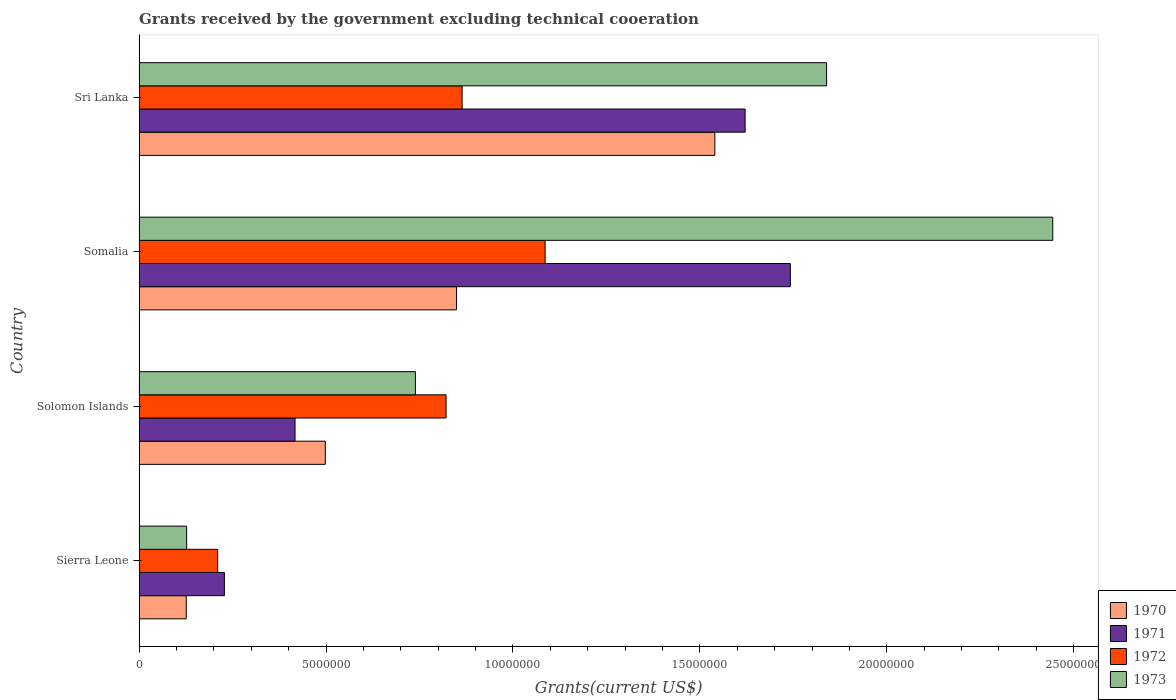How many different coloured bars are there?
Your answer should be compact. 4. Are the number of bars on each tick of the Y-axis equal?
Provide a succinct answer. Yes. How many bars are there on the 2nd tick from the top?
Provide a short and direct response. 4. How many bars are there on the 2nd tick from the bottom?
Keep it short and to the point. 4. What is the label of the 3rd group of bars from the top?
Keep it short and to the point. Solomon Islands. In how many cases, is the number of bars for a given country not equal to the number of legend labels?
Your response must be concise. 0. What is the total grants received by the government in 1970 in Sierra Leone?
Your answer should be very brief. 1.26e+06. Across all countries, what is the maximum total grants received by the government in 1973?
Ensure brevity in your answer.  2.44e+07. Across all countries, what is the minimum total grants received by the government in 1973?
Your response must be concise. 1.27e+06. In which country was the total grants received by the government in 1971 maximum?
Provide a succinct answer. Somalia. In which country was the total grants received by the government in 1973 minimum?
Your answer should be very brief. Sierra Leone. What is the total total grants received by the government in 1970 in the graph?
Ensure brevity in your answer.  3.01e+07. What is the difference between the total grants received by the government in 1972 in Sierra Leone and that in Somalia?
Offer a terse response. -8.76e+06. What is the difference between the total grants received by the government in 1971 in Somalia and the total grants received by the government in 1970 in Solomon Islands?
Offer a very short reply. 1.24e+07. What is the average total grants received by the government in 1970 per country?
Offer a terse response. 7.53e+06. What is the difference between the total grants received by the government in 1970 and total grants received by the government in 1971 in Somalia?
Provide a succinct answer. -8.93e+06. In how many countries, is the total grants received by the government in 1973 greater than 1000000 US$?
Provide a succinct answer. 4. What is the ratio of the total grants received by the government in 1972 in Solomon Islands to that in Somalia?
Offer a terse response. 0.76. What is the difference between the highest and the second highest total grants received by the government in 1970?
Your answer should be very brief. 6.91e+06. What is the difference between the highest and the lowest total grants received by the government in 1971?
Ensure brevity in your answer.  1.51e+07. What does the 3rd bar from the top in Sierra Leone represents?
Your response must be concise. 1971. What does the 2nd bar from the bottom in Solomon Islands represents?
Your answer should be very brief. 1971. Is it the case that in every country, the sum of the total grants received by the government in 1973 and total grants received by the government in 1970 is greater than the total grants received by the government in 1972?
Give a very brief answer. Yes. How many bars are there?
Your answer should be very brief. 16. Are all the bars in the graph horizontal?
Offer a terse response. Yes. What is the difference between two consecutive major ticks on the X-axis?
Make the answer very short. 5.00e+06. Does the graph contain any zero values?
Provide a succinct answer. No. Where does the legend appear in the graph?
Provide a succinct answer. Bottom right. How many legend labels are there?
Give a very brief answer. 4. How are the legend labels stacked?
Your response must be concise. Vertical. What is the title of the graph?
Give a very brief answer. Grants received by the government excluding technical cooeration. Does "2009" appear as one of the legend labels in the graph?
Offer a terse response. No. What is the label or title of the X-axis?
Provide a short and direct response. Grants(current US$). What is the label or title of the Y-axis?
Your response must be concise. Country. What is the Grants(current US$) in 1970 in Sierra Leone?
Keep it short and to the point. 1.26e+06. What is the Grants(current US$) in 1971 in Sierra Leone?
Your response must be concise. 2.28e+06. What is the Grants(current US$) of 1972 in Sierra Leone?
Give a very brief answer. 2.10e+06. What is the Grants(current US$) of 1973 in Sierra Leone?
Offer a very short reply. 1.27e+06. What is the Grants(current US$) of 1970 in Solomon Islands?
Offer a terse response. 4.98e+06. What is the Grants(current US$) of 1971 in Solomon Islands?
Ensure brevity in your answer.  4.17e+06. What is the Grants(current US$) in 1972 in Solomon Islands?
Offer a terse response. 8.21e+06. What is the Grants(current US$) in 1973 in Solomon Islands?
Make the answer very short. 7.39e+06. What is the Grants(current US$) in 1970 in Somalia?
Ensure brevity in your answer.  8.49e+06. What is the Grants(current US$) of 1971 in Somalia?
Offer a terse response. 1.74e+07. What is the Grants(current US$) in 1972 in Somalia?
Offer a terse response. 1.09e+07. What is the Grants(current US$) in 1973 in Somalia?
Your answer should be very brief. 2.44e+07. What is the Grants(current US$) of 1970 in Sri Lanka?
Provide a short and direct response. 1.54e+07. What is the Grants(current US$) in 1971 in Sri Lanka?
Your answer should be compact. 1.62e+07. What is the Grants(current US$) in 1972 in Sri Lanka?
Provide a short and direct response. 8.64e+06. What is the Grants(current US$) in 1973 in Sri Lanka?
Ensure brevity in your answer.  1.84e+07. Across all countries, what is the maximum Grants(current US$) of 1970?
Provide a short and direct response. 1.54e+07. Across all countries, what is the maximum Grants(current US$) in 1971?
Ensure brevity in your answer.  1.74e+07. Across all countries, what is the maximum Grants(current US$) of 1972?
Ensure brevity in your answer.  1.09e+07. Across all countries, what is the maximum Grants(current US$) of 1973?
Give a very brief answer. 2.44e+07. Across all countries, what is the minimum Grants(current US$) of 1970?
Your answer should be very brief. 1.26e+06. Across all countries, what is the minimum Grants(current US$) in 1971?
Ensure brevity in your answer.  2.28e+06. Across all countries, what is the minimum Grants(current US$) of 1972?
Provide a succinct answer. 2.10e+06. Across all countries, what is the minimum Grants(current US$) in 1973?
Give a very brief answer. 1.27e+06. What is the total Grants(current US$) in 1970 in the graph?
Your response must be concise. 3.01e+07. What is the total Grants(current US$) of 1971 in the graph?
Make the answer very short. 4.01e+07. What is the total Grants(current US$) of 1972 in the graph?
Your response must be concise. 2.98e+07. What is the total Grants(current US$) in 1973 in the graph?
Make the answer very short. 5.15e+07. What is the difference between the Grants(current US$) in 1970 in Sierra Leone and that in Solomon Islands?
Give a very brief answer. -3.72e+06. What is the difference between the Grants(current US$) in 1971 in Sierra Leone and that in Solomon Islands?
Offer a very short reply. -1.89e+06. What is the difference between the Grants(current US$) of 1972 in Sierra Leone and that in Solomon Islands?
Ensure brevity in your answer.  -6.11e+06. What is the difference between the Grants(current US$) of 1973 in Sierra Leone and that in Solomon Islands?
Offer a terse response. -6.12e+06. What is the difference between the Grants(current US$) of 1970 in Sierra Leone and that in Somalia?
Provide a short and direct response. -7.23e+06. What is the difference between the Grants(current US$) of 1971 in Sierra Leone and that in Somalia?
Provide a succinct answer. -1.51e+07. What is the difference between the Grants(current US$) of 1972 in Sierra Leone and that in Somalia?
Provide a short and direct response. -8.76e+06. What is the difference between the Grants(current US$) of 1973 in Sierra Leone and that in Somalia?
Make the answer very short. -2.32e+07. What is the difference between the Grants(current US$) of 1970 in Sierra Leone and that in Sri Lanka?
Make the answer very short. -1.41e+07. What is the difference between the Grants(current US$) in 1971 in Sierra Leone and that in Sri Lanka?
Ensure brevity in your answer.  -1.39e+07. What is the difference between the Grants(current US$) of 1972 in Sierra Leone and that in Sri Lanka?
Offer a very short reply. -6.54e+06. What is the difference between the Grants(current US$) in 1973 in Sierra Leone and that in Sri Lanka?
Provide a succinct answer. -1.71e+07. What is the difference between the Grants(current US$) in 1970 in Solomon Islands and that in Somalia?
Your answer should be very brief. -3.51e+06. What is the difference between the Grants(current US$) in 1971 in Solomon Islands and that in Somalia?
Offer a terse response. -1.32e+07. What is the difference between the Grants(current US$) of 1972 in Solomon Islands and that in Somalia?
Make the answer very short. -2.65e+06. What is the difference between the Grants(current US$) in 1973 in Solomon Islands and that in Somalia?
Make the answer very short. -1.70e+07. What is the difference between the Grants(current US$) of 1970 in Solomon Islands and that in Sri Lanka?
Ensure brevity in your answer.  -1.04e+07. What is the difference between the Grants(current US$) of 1971 in Solomon Islands and that in Sri Lanka?
Offer a very short reply. -1.20e+07. What is the difference between the Grants(current US$) of 1972 in Solomon Islands and that in Sri Lanka?
Your answer should be very brief. -4.30e+05. What is the difference between the Grants(current US$) in 1973 in Solomon Islands and that in Sri Lanka?
Keep it short and to the point. -1.10e+07. What is the difference between the Grants(current US$) in 1970 in Somalia and that in Sri Lanka?
Provide a succinct answer. -6.91e+06. What is the difference between the Grants(current US$) in 1971 in Somalia and that in Sri Lanka?
Keep it short and to the point. 1.21e+06. What is the difference between the Grants(current US$) of 1972 in Somalia and that in Sri Lanka?
Offer a very short reply. 2.22e+06. What is the difference between the Grants(current US$) in 1973 in Somalia and that in Sri Lanka?
Provide a succinct answer. 6.05e+06. What is the difference between the Grants(current US$) of 1970 in Sierra Leone and the Grants(current US$) of 1971 in Solomon Islands?
Your response must be concise. -2.91e+06. What is the difference between the Grants(current US$) of 1970 in Sierra Leone and the Grants(current US$) of 1972 in Solomon Islands?
Your response must be concise. -6.95e+06. What is the difference between the Grants(current US$) of 1970 in Sierra Leone and the Grants(current US$) of 1973 in Solomon Islands?
Keep it short and to the point. -6.13e+06. What is the difference between the Grants(current US$) in 1971 in Sierra Leone and the Grants(current US$) in 1972 in Solomon Islands?
Your response must be concise. -5.93e+06. What is the difference between the Grants(current US$) of 1971 in Sierra Leone and the Grants(current US$) of 1973 in Solomon Islands?
Keep it short and to the point. -5.11e+06. What is the difference between the Grants(current US$) in 1972 in Sierra Leone and the Grants(current US$) in 1973 in Solomon Islands?
Ensure brevity in your answer.  -5.29e+06. What is the difference between the Grants(current US$) of 1970 in Sierra Leone and the Grants(current US$) of 1971 in Somalia?
Your response must be concise. -1.62e+07. What is the difference between the Grants(current US$) of 1970 in Sierra Leone and the Grants(current US$) of 1972 in Somalia?
Ensure brevity in your answer.  -9.60e+06. What is the difference between the Grants(current US$) of 1970 in Sierra Leone and the Grants(current US$) of 1973 in Somalia?
Offer a terse response. -2.32e+07. What is the difference between the Grants(current US$) in 1971 in Sierra Leone and the Grants(current US$) in 1972 in Somalia?
Make the answer very short. -8.58e+06. What is the difference between the Grants(current US$) in 1971 in Sierra Leone and the Grants(current US$) in 1973 in Somalia?
Your response must be concise. -2.22e+07. What is the difference between the Grants(current US$) in 1972 in Sierra Leone and the Grants(current US$) in 1973 in Somalia?
Provide a short and direct response. -2.23e+07. What is the difference between the Grants(current US$) of 1970 in Sierra Leone and the Grants(current US$) of 1971 in Sri Lanka?
Provide a short and direct response. -1.50e+07. What is the difference between the Grants(current US$) in 1970 in Sierra Leone and the Grants(current US$) in 1972 in Sri Lanka?
Offer a very short reply. -7.38e+06. What is the difference between the Grants(current US$) of 1970 in Sierra Leone and the Grants(current US$) of 1973 in Sri Lanka?
Your answer should be very brief. -1.71e+07. What is the difference between the Grants(current US$) in 1971 in Sierra Leone and the Grants(current US$) in 1972 in Sri Lanka?
Keep it short and to the point. -6.36e+06. What is the difference between the Grants(current US$) of 1971 in Sierra Leone and the Grants(current US$) of 1973 in Sri Lanka?
Your response must be concise. -1.61e+07. What is the difference between the Grants(current US$) of 1972 in Sierra Leone and the Grants(current US$) of 1973 in Sri Lanka?
Provide a short and direct response. -1.63e+07. What is the difference between the Grants(current US$) in 1970 in Solomon Islands and the Grants(current US$) in 1971 in Somalia?
Make the answer very short. -1.24e+07. What is the difference between the Grants(current US$) of 1970 in Solomon Islands and the Grants(current US$) of 1972 in Somalia?
Your answer should be compact. -5.88e+06. What is the difference between the Grants(current US$) of 1970 in Solomon Islands and the Grants(current US$) of 1973 in Somalia?
Provide a short and direct response. -1.95e+07. What is the difference between the Grants(current US$) in 1971 in Solomon Islands and the Grants(current US$) in 1972 in Somalia?
Ensure brevity in your answer.  -6.69e+06. What is the difference between the Grants(current US$) in 1971 in Solomon Islands and the Grants(current US$) in 1973 in Somalia?
Offer a terse response. -2.03e+07. What is the difference between the Grants(current US$) of 1972 in Solomon Islands and the Grants(current US$) of 1973 in Somalia?
Your response must be concise. -1.62e+07. What is the difference between the Grants(current US$) in 1970 in Solomon Islands and the Grants(current US$) in 1971 in Sri Lanka?
Your response must be concise. -1.12e+07. What is the difference between the Grants(current US$) of 1970 in Solomon Islands and the Grants(current US$) of 1972 in Sri Lanka?
Make the answer very short. -3.66e+06. What is the difference between the Grants(current US$) of 1970 in Solomon Islands and the Grants(current US$) of 1973 in Sri Lanka?
Your response must be concise. -1.34e+07. What is the difference between the Grants(current US$) of 1971 in Solomon Islands and the Grants(current US$) of 1972 in Sri Lanka?
Ensure brevity in your answer.  -4.47e+06. What is the difference between the Grants(current US$) in 1971 in Solomon Islands and the Grants(current US$) in 1973 in Sri Lanka?
Offer a very short reply. -1.42e+07. What is the difference between the Grants(current US$) of 1972 in Solomon Islands and the Grants(current US$) of 1973 in Sri Lanka?
Offer a terse response. -1.02e+07. What is the difference between the Grants(current US$) of 1970 in Somalia and the Grants(current US$) of 1971 in Sri Lanka?
Give a very brief answer. -7.72e+06. What is the difference between the Grants(current US$) of 1970 in Somalia and the Grants(current US$) of 1973 in Sri Lanka?
Provide a succinct answer. -9.90e+06. What is the difference between the Grants(current US$) in 1971 in Somalia and the Grants(current US$) in 1972 in Sri Lanka?
Offer a very short reply. 8.78e+06. What is the difference between the Grants(current US$) of 1971 in Somalia and the Grants(current US$) of 1973 in Sri Lanka?
Keep it short and to the point. -9.70e+05. What is the difference between the Grants(current US$) in 1972 in Somalia and the Grants(current US$) in 1973 in Sri Lanka?
Offer a very short reply. -7.53e+06. What is the average Grants(current US$) in 1970 per country?
Make the answer very short. 7.53e+06. What is the average Grants(current US$) in 1971 per country?
Ensure brevity in your answer.  1.00e+07. What is the average Grants(current US$) of 1972 per country?
Give a very brief answer. 7.45e+06. What is the average Grants(current US$) in 1973 per country?
Keep it short and to the point. 1.29e+07. What is the difference between the Grants(current US$) of 1970 and Grants(current US$) of 1971 in Sierra Leone?
Your answer should be very brief. -1.02e+06. What is the difference between the Grants(current US$) of 1970 and Grants(current US$) of 1972 in Sierra Leone?
Provide a succinct answer. -8.40e+05. What is the difference between the Grants(current US$) in 1970 and Grants(current US$) in 1973 in Sierra Leone?
Your response must be concise. -10000. What is the difference between the Grants(current US$) of 1971 and Grants(current US$) of 1972 in Sierra Leone?
Make the answer very short. 1.80e+05. What is the difference between the Grants(current US$) of 1971 and Grants(current US$) of 1973 in Sierra Leone?
Your answer should be compact. 1.01e+06. What is the difference between the Grants(current US$) of 1972 and Grants(current US$) of 1973 in Sierra Leone?
Make the answer very short. 8.30e+05. What is the difference between the Grants(current US$) in 1970 and Grants(current US$) in 1971 in Solomon Islands?
Ensure brevity in your answer.  8.10e+05. What is the difference between the Grants(current US$) in 1970 and Grants(current US$) in 1972 in Solomon Islands?
Give a very brief answer. -3.23e+06. What is the difference between the Grants(current US$) in 1970 and Grants(current US$) in 1973 in Solomon Islands?
Provide a short and direct response. -2.41e+06. What is the difference between the Grants(current US$) of 1971 and Grants(current US$) of 1972 in Solomon Islands?
Make the answer very short. -4.04e+06. What is the difference between the Grants(current US$) of 1971 and Grants(current US$) of 1973 in Solomon Islands?
Keep it short and to the point. -3.22e+06. What is the difference between the Grants(current US$) in 1972 and Grants(current US$) in 1973 in Solomon Islands?
Offer a terse response. 8.20e+05. What is the difference between the Grants(current US$) in 1970 and Grants(current US$) in 1971 in Somalia?
Provide a short and direct response. -8.93e+06. What is the difference between the Grants(current US$) of 1970 and Grants(current US$) of 1972 in Somalia?
Keep it short and to the point. -2.37e+06. What is the difference between the Grants(current US$) in 1970 and Grants(current US$) in 1973 in Somalia?
Offer a terse response. -1.60e+07. What is the difference between the Grants(current US$) in 1971 and Grants(current US$) in 1972 in Somalia?
Your response must be concise. 6.56e+06. What is the difference between the Grants(current US$) in 1971 and Grants(current US$) in 1973 in Somalia?
Ensure brevity in your answer.  -7.02e+06. What is the difference between the Grants(current US$) of 1972 and Grants(current US$) of 1973 in Somalia?
Offer a terse response. -1.36e+07. What is the difference between the Grants(current US$) of 1970 and Grants(current US$) of 1971 in Sri Lanka?
Offer a very short reply. -8.10e+05. What is the difference between the Grants(current US$) of 1970 and Grants(current US$) of 1972 in Sri Lanka?
Keep it short and to the point. 6.76e+06. What is the difference between the Grants(current US$) in 1970 and Grants(current US$) in 1973 in Sri Lanka?
Your answer should be very brief. -2.99e+06. What is the difference between the Grants(current US$) of 1971 and Grants(current US$) of 1972 in Sri Lanka?
Your answer should be compact. 7.57e+06. What is the difference between the Grants(current US$) in 1971 and Grants(current US$) in 1973 in Sri Lanka?
Your response must be concise. -2.18e+06. What is the difference between the Grants(current US$) of 1972 and Grants(current US$) of 1973 in Sri Lanka?
Make the answer very short. -9.75e+06. What is the ratio of the Grants(current US$) in 1970 in Sierra Leone to that in Solomon Islands?
Make the answer very short. 0.25. What is the ratio of the Grants(current US$) in 1971 in Sierra Leone to that in Solomon Islands?
Give a very brief answer. 0.55. What is the ratio of the Grants(current US$) of 1972 in Sierra Leone to that in Solomon Islands?
Your answer should be compact. 0.26. What is the ratio of the Grants(current US$) in 1973 in Sierra Leone to that in Solomon Islands?
Provide a succinct answer. 0.17. What is the ratio of the Grants(current US$) in 1970 in Sierra Leone to that in Somalia?
Provide a succinct answer. 0.15. What is the ratio of the Grants(current US$) of 1971 in Sierra Leone to that in Somalia?
Ensure brevity in your answer.  0.13. What is the ratio of the Grants(current US$) in 1972 in Sierra Leone to that in Somalia?
Your answer should be very brief. 0.19. What is the ratio of the Grants(current US$) of 1973 in Sierra Leone to that in Somalia?
Offer a very short reply. 0.05. What is the ratio of the Grants(current US$) in 1970 in Sierra Leone to that in Sri Lanka?
Offer a terse response. 0.08. What is the ratio of the Grants(current US$) in 1971 in Sierra Leone to that in Sri Lanka?
Make the answer very short. 0.14. What is the ratio of the Grants(current US$) in 1972 in Sierra Leone to that in Sri Lanka?
Offer a very short reply. 0.24. What is the ratio of the Grants(current US$) of 1973 in Sierra Leone to that in Sri Lanka?
Ensure brevity in your answer.  0.07. What is the ratio of the Grants(current US$) in 1970 in Solomon Islands to that in Somalia?
Ensure brevity in your answer.  0.59. What is the ratio of the Grants(current US$) in 1971 in Solomon Islands to that in Somalia?
Offer a very short reply. 0.24. What is the ratio of the Grants(current US$) in 1972 in Solomon Islands to that in Somalia?
Your response must be concise. 0.76. What is the ratio of the Grants(current US$) in 1973 in Solomon Islands to that in Somalia?
Your answer should be very brief. 0.3. What is the ratio of the Grants(current US$) in 1970 in Solomon Islands to that in Sri Lanka?
Give a very brief answer. 0.32. What is the ratio of the Grants(current US$) in 1971 in Solomon Islands to that in Sri Lanka?
Your response must be concise. 0.26. What is the ratio of the Grants(current US$) of 1972 in Solomon Islands to that in Sri Lanka?
Your response must be concise. 0.95. What is the ratio of the Grants(current US$) in 1973 in Solomon Islands to that in Sri Lanka?
Offer a terse response. 0.4. What is the ratio of the Grants(current US$) of 1970 in Somalia to that in Sri Lanka?
Offer a very short reply. 0.55. What is the ratio of the Grants(current US$) in 1971 in Somalia to that in Sri Lanka?
Provide a short and direct response. 1.07. What is the ratio of the Grants(current US$) in 1972 in Somalia to that in Sri Lanka?
Ensure brevity in your answer.  1.26. What is the ratio of the Grants(current US$) of 1973 in Somalia to that in Sri Lanka?
Provide a short and direct response. 1.33. What is the difference between the highest and the second highest Grants(current US$) in 1970?
Your answer should be very brief. 6.91e+06. What is the difference between the highest and the second highest Grants(current US$) in 1971?
Offer a terse response. 1.21e+06. What is the difference between the highest and the second highest Grants(current US$) of 1972?
Offer a very short reply. 2.22e+06. What is the difference between the highest and the second highest Grants(current US$) in 1973?
Provide a short and direct response. 6.05e+06. What is the difference between the highest and the lowest Grants(current US$) in 1970?
Keep it short and to the point. 1.41e+07. What is the difference between the highest and the lowest Grants(current US$) of 1971?
Give a very brief answer. 1.51e+07. What is the difference between the highest and the lowest Grants(current US$) in 1972?
Offer a very short reply. 8.76e+06. What is the difference between the highest and the lowest Grants(current US$) of 1973?
Give a very brief answer. 2.32e+07. 